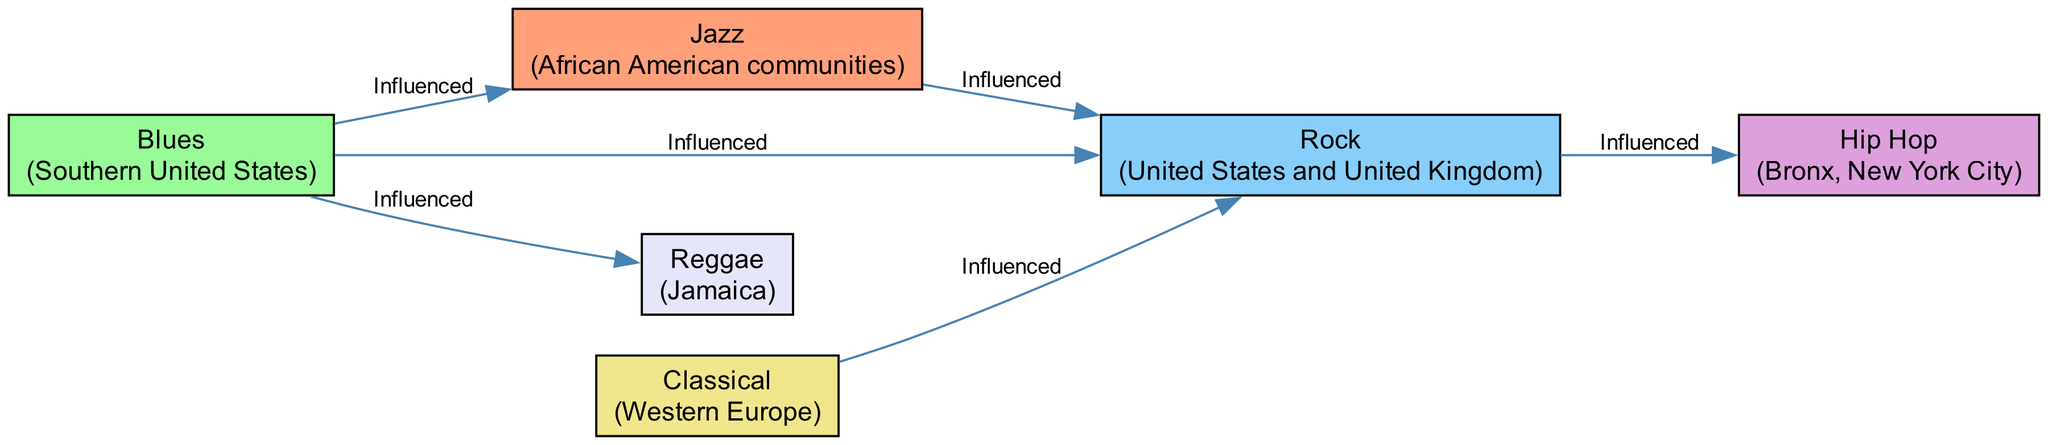What is the cultural origin of Jazz? The diagram indicates that Jazz originated in African American communities. This information is derived from the node labeled "Jazz" which clearly states its origin.
Answer: African American communities Which genre influenced the most genres in the diagram? By reviewing the edges connected to the nodes, Blues influences Jazz, Rock, and Reggae, making it the genre that influences the most other genres in this diagram. Thus, it is also connected to more edges than any other node.
Answer: Blues How many nodes are there in the diagram? Counting all the unique musical genres represented as nodes, there are a total of six nodes present in the diagram.
Answer: 6 What genres are influenced by Classical music? The diagram shows that Classical music has a direct edge influencing Rock. No other connections are made from Classical to other genres in this diagram, therefore, Rock is the only genre influenced by Classical.
Answer: Rock Which two genres have a direct influence relationship according to the diagram? The diagram depicts several direct influence relationships such as Blues to Jazz and Jazz to Rock, meaning these pairs have a clear directional influence indicated by edges. Checking the direct connections, Blues influences Jazz and Jazz influences Rock.
Answer: Blues to Jazz Which genre originated from Bronx, New York City? The diagram has a node labeled "Hip Hop," stating its origin as Bronx, New York City. This is a straightforward fact presented in the diagram.
Answer: Hip Hop Which two genres are connected to Reggae? The diagram shows edges originating from Blues leading to Reggae. Therefore, the only visible connection by influence is between Blues and Reggae. We can also mention that Blues is the precursor, making its relationship evident.
Answer: Blues How many total influence relationships (edges) are depicted in the diagram? Counting the edges in the diagram, there are a total of six influence relationships depicted between the various musical genres represented.
Answer: 6 Which genre is influenced by both Blues and Classical? By investigating the influences in the diagram, it is clear that Rock is the genre that is influenced by both Blues and Classical genres, as shown by the edges pointing towards Rock from both.
Answer: Rock 